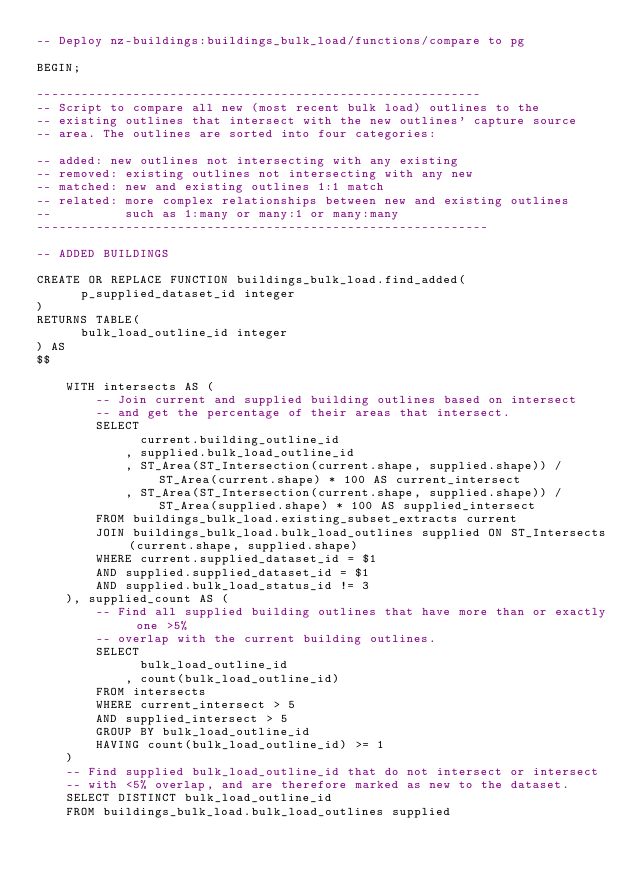<code> <loc_0><loc_0><loc_500><loc_500><_SQL_>-- Deploy nz-buildings:buildings_bulk_load/functions/compare to pg

BEGIN;

------------------------------------------------------------
-- Script to compare all new (most recent bulk load) outlines to the
-- existing outlines that intersect with the new outlines' capture source
-- area. The outlines are sorted into four categories:

-- added: new outlines not intersecting with any existing
-- removed: existing outlines not intersecting with any new
-- matched: new and existing outlines 1:1 match
-- related: more complex relationships between new and existing outlines
--          such as 1:many or many:1 or many:many
-------------------------------------------------------------

-- ADDED BUILDINGS

CREATE OR REPLACE FUNCTION buildings_bulk_load.find_added(
      p_supplied_dataset_id integer
)
RETURNS TABLE(
      bulk_load_outline_id integer
) AS
$$

    WITH intersects AS (
        -- Join current and supplied building outlines based on intersect
        -- and get the percentage of their areas that intersect.
        SELECT
              current.building_outline_id
            , supplied.bulk_load_outline_id
            , ST_Area(ST_Intersection(current.shape, supplied.shape)) / ST_Area(current.shape) * 100 AS current_intersect
            , ST_Area(ST_Intersection(current.shape, supplied.shape)) / ST_Area(supplied.shape) * 100 AS supplied_intersect
        FROM buildings_bulk_load.existing_subset_extracts current
        JOIN buildings_bulk_load.bulk_load_outlines supplied ON ST_Intersects(current.shape, supplied.shape)
        WHERE current.supplied_dataset_id = $1
        AND supplied.supplied_dataset_id = $1
        AND supplied.bulk_load_status_id != 3
    ), supplied_count AS (
        -- Find all supplied building outlines that have more than or exactly one >5%
        -- overlap with the current building outlines.
        SELECT
              bulk_load_outline_id
            , count(bulk_load_outline_id)
        FROM intersects
        WHERE current_intersect > 5
        AND supplied_intersect > 5
        GROUP BY bulk_load_outline_id
        HAVING count(bulk_load_outline_id) >= 1
    )
    -- Find supplied bulk_load_outline_id that do not intersect or intersect
    -- with <5% overlap, and are therefore marked as new to the dataset.
    SELECT DISTINCT bulk_load_outline_id
    FROM buildings_bulk_load.bulk_load_outlines supplied</code> 